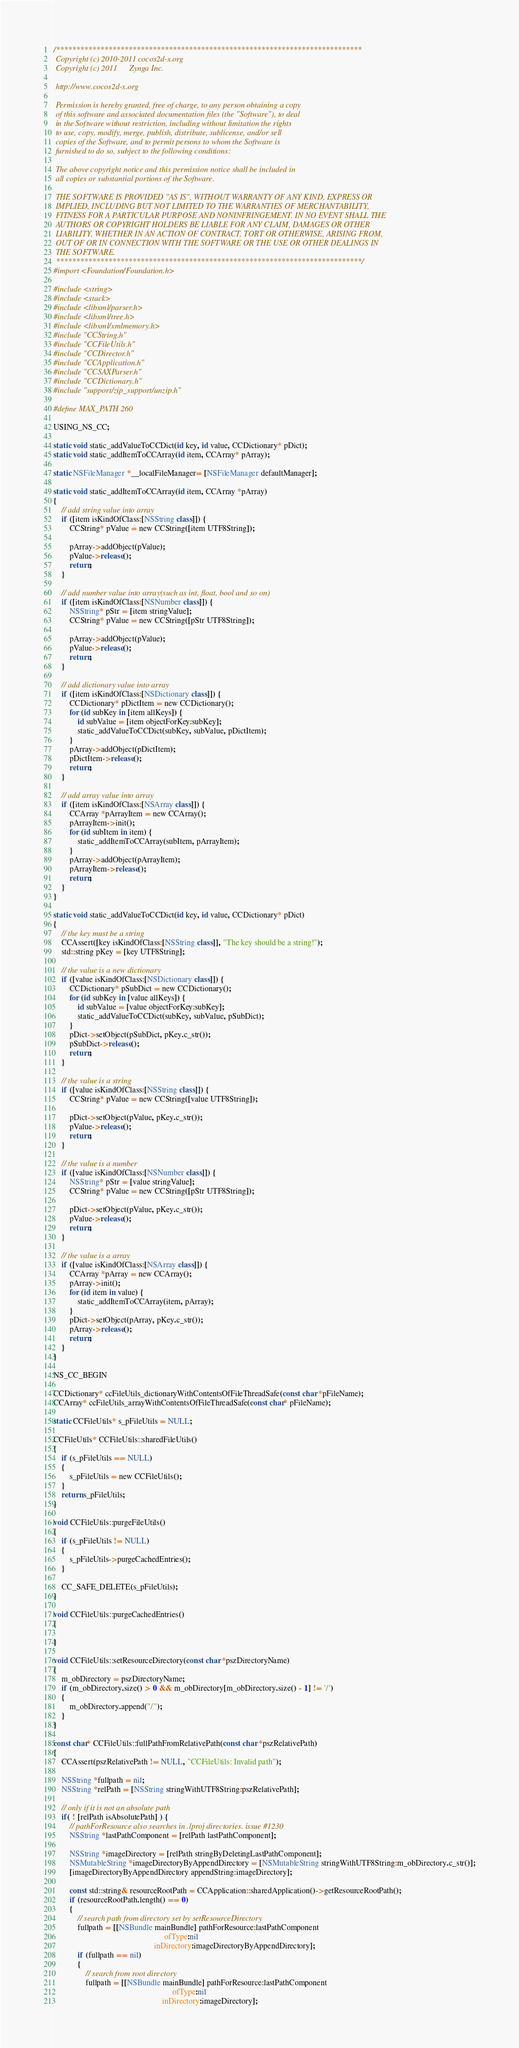Convert code to text. <code><loc_0><loc_0><loc_500><loc_500><_ObjectiveC_>/****************************************************************************
 Copyright (c) 2010-2011 cocos2d-x.org
 Copyright (c) 2011      Zynga Inc.
 
 http://www.cocos2d-x.org
 
 Permission is hereby granted, free of charge, to any person obtaining a copy
 of this software and associated documentation files (the "Software"), to deal
 in the Software without restriction, including without limitation the rights
 to use, copy, modify, merge, publish, distribute, sublicense, and/or sell
 copies of the Software, and to permit persons to whom the Software is
 furnished to do so, subject to the following conditions:
 
 The above copyright notice and this permission notice shall be included in
 all copies or substantial portions of the Software.
 
 THE SOFTWARE IS PROVIDED "AS IS", WITHOUT WARRANTY OF ANY KIND, EXPRESS OR
 IMPLIED, INCLUDING BUT NOT LIMITED TO THE WARRANTIES OF MERCHANTABILITY,
 FITNESS FOR A PARTICULAR PURPOSE AND NONINFRINGEMENT. IN NO EVENT SHALL THE
 AUTHORS OR COPYRIGHT HOLDERS BE LIABLE FOR ANY CLAIM, DAMAGES OR OTHER
 LIABILITY, WHETHER IN AN ACTION OF CONTRACT, TORT OR OTHERWISE, ARISING FROM,
 OUT OF OR IN CONNECTION WITH THE SOFTWARE OR THE USE OR OTHER DEALINGS IN
 THE SOFTWARE.
 ****************************************************************************/
#import <Foundation/Foundation.h>

#include <string>
#include <stack>
#include <libxml/parser.h>
#include <libxml/tree.h>
#include <libxml/xmlmemory.h>
#include "CCString.h"
#include "CCFileUtils.h"
#include "CCDirector.h"
#include "CCApplication.h"
#include "CCSAXParser.h"
#include "CCDictionary.h"
#include "support/zip_support/unzip.h"

#define MAX_PATH 260

USING_NS_CC;

static void static_addValueToCCDict(id key, id value, CCDictionary* pDict);
static void static_addItemToCCArray(id item, CCArray* pArray);

static NSFileManager *__localFileManager= [NSFileManager defaultManager];

static void static_addItemToCCArray(id item, CCArray *pArray)
{
    // add string value into array
    if ([item isKindOfClass:[NSString class]]) {
        CCString* pValue = new CCString([item UTF8String]);
        
        pArray->addObject(pValue);
        pValue->release();
        return;
    }
    
    // add number value into array(such as int, float, bool and so on)
    if ([item isKindOfClass:[NSNumber class]]) {
        NSString* pStr = [item stringValue];
        CCString* pValue = new CCString([pStr UTF8String]);
        
        pArray->addObject(pValue);
        pValue->release();
        return;
    }
    
    // add dictionary value into array
    if ([item isKindOfClass:[NSDictionary class]]) {
        CCDictionary* pDictItem = new CCDictionary();
        for (id subKey in [item allKeys]) {
            id subValue = [item objectForKey:subKey];
            static_addValueToCCDict(subKey, subValue, pDictItem);
        }
        pArray->addObject(pDictItem);
        pDictItem->release();
        return;
    }
    
    // add array value into array
    if ([item isKindOfClass:[NSArray class]]) {
        CCArray *pArrayItem = new CCArray();
        pArrayItem->init();
        for (id subItem in item) {
            static_addItemToCCArray(subItem, pArrayItem);
        }
        pArray->addObject(pArrayItem);
        pArrayItem->release();
        return;
    }
}

static void static_addValueToCCDict(id key, id value, CCDictionary* pDict)
{
    // the key must be a string
    CCAssert([key isKindOfClass:[NSString class]], "The key should be a string!");
    std::string pKey = [key UTF8String];
    
    // the value is a new dictionary
    if ([value isKindOfClass:[NSDictionary class]]) {
        CCDictionary* pSubDict = new CCDictionary();
        for (id subKey in [value allKeys]) {
            id subValue = [value objectForKey:subKey];
            static_addValueToCCDict(subKey, subValue, pSubDict);
        }
        pDict->setObject(pSubDict, pKey.c_str());
        pSubDict->release();
        return;
    }
    
    // the value is a string
    if ([value isKindOfClass:[NSString class]]) {
        CCString* pValue = new CCString([value UTF8String]);
        
        pDict->setObject(pValue, pKey.c_str());
        pValue->release();
        return;
    }
    
    // the value is a number
    if ([value isKindOfClass:[NSNumber class]]) {
        NSString* pStr = [value stringValue];
        CCString* pValue = new CCString([pStr UTF8String]);
        
        pDict->setObject(pValue, pKey.c_str());
        pValue->release();
        return;
    }
    
    // the value is a array
    if ([value isKindOfClass:[NSArray class]]) {
        CCArray *pArray = new CCArray();
        pArray->init();
        for (id item in value) {
            static_addItemToCCArray(item, pArray);
        }
        pDict->setObject(pArray, pKey.c_str());
        pArray->release();
        return;
    }
}

NS_CC_BEGIN

CCDictionary* ccFileUtils_dictionaryWithContentsOfFileThreadSafe(const char *pFileName);
CCArray* ccFileUtils_arrayWithContentsOfFileThreadSafe(const char* pFileName);

static CCFileUtils* s_pFileUtils = NULL;

CCFileUtils* CCFileUtils::sharedFileUtils()
{
    if (s_pFileUtils == NULL)
    {
        s_pFileUtils = new CCFileUtils();
    }
    return s_pFileUtils;
}

void CCFileUtils::purgeFileUtils()
{
    if (s_pFileUtils != NULL)
    {
        s_pFileUtils->purgeCachedEntries();
    }
    
    CC_SAFE_DELETE(s_pFileUtils);
}

void CCFileUtils::purgeCachedEntries()
{
    
}

void CCFileUtils::setResourceDirectory(const char *pszDirectoryName)
{
    m_obDirectory = pszDirectoryName;
    if (m_obDirectory.size() > 0 && m_obDirectory[m_obDirectory.size() - 1] != '/')
    {
        m_obDirectory.append("/");
    }
}

const char* CCFileUtils::fullPathFromRelativePath(const char *pszRelativePath)
{
    CCAssert(pszRelativePath != NULL, "CCFileUtils: Invalid path");
    
    NSString *fullpath = nil;
    NSString *relPath = [NSString stringWithUTF8String:pszRelativePath];
    
    // only if it is not an absolute path
    if( ! [relPath isAbsolutePath] ) {
        // pathForResource also searches in .lproj directories. issue #1230
        NSString *lastPathComponent = [relPath lastPathComponent];
        
        NSString *imageDirectory = [relPath stringByDeletingLastPathComponent];
        NSMutableString *imageDirectoryByAppendDirectory = [NSMutableString stringWithUTF8String:m_obDirectory.c_str()];
        [imageDirectoryByAppendDirectory appendString:imageDirectory];
        
        const std::string& resourceRootPath = CCApplication::sharedApplication()->getResourceRootPath();
        if (resourceRootPath.length() == 0)
        {
            // search path from directory set by setResourceDirectory
            fullpath = [[NSBundle mainBundle] pathForResource:lastPathComponent
                                                       ofType:nil
                                                  inDirectory:imageDirectoryByAppendDirectory];
            if (fullpath == nil)
            {
                // search from root directory
                fullpath = [[NSBundle mainBundle] pathForResource:lastPathComponent
                                                           ofType:nil
                                                      inDirectory:imageDirectory];</code> 